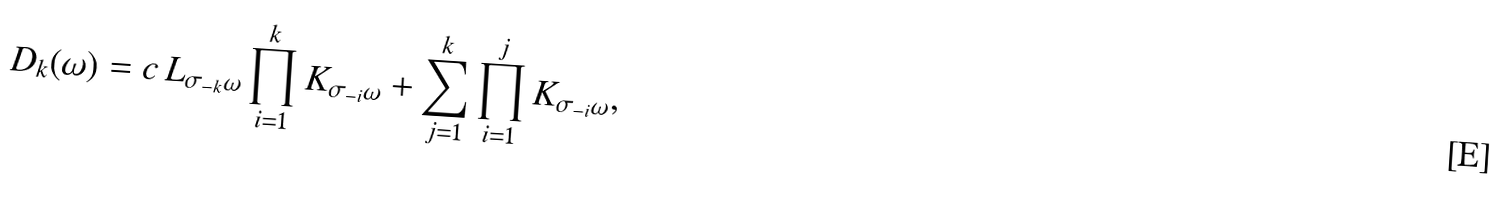<formula> <loc_0><loc_0><loc_500><loc_500>D _ { k } ( \omega ) = c \, L _ { \sigma _ { - k } \omega } \prod _ { i = 1 } ^ { k } K _ { \sigma _ { - i } \omega } + \sum _ { j = 1 } ^ { k } \prod _ { i = 1 } ^ { j } K _ { \sigma _ { - i } \omega } ,</formula> 